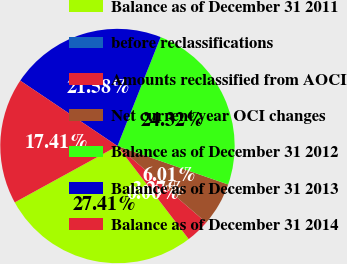<chart> <loc_0><loc_0><loc_500><loc_500><pie_chart><fcel>Balance as of December 31 2011<fcel>before reclassifications<fcel>Amounts reclassified from AOCI<fcel>Net current year OCI changes<fcel>Balance as of December 31 2012<fcel>Balance as of December 31 2013<fcel>Balance as of December 31 2014<nl><fcel>27.41%<fcel>0.0%<fcel>3.27%<fcel>6.01%<fcel>24.32%<fcel>21.58%<fcel>17.41%<nl></chart> 